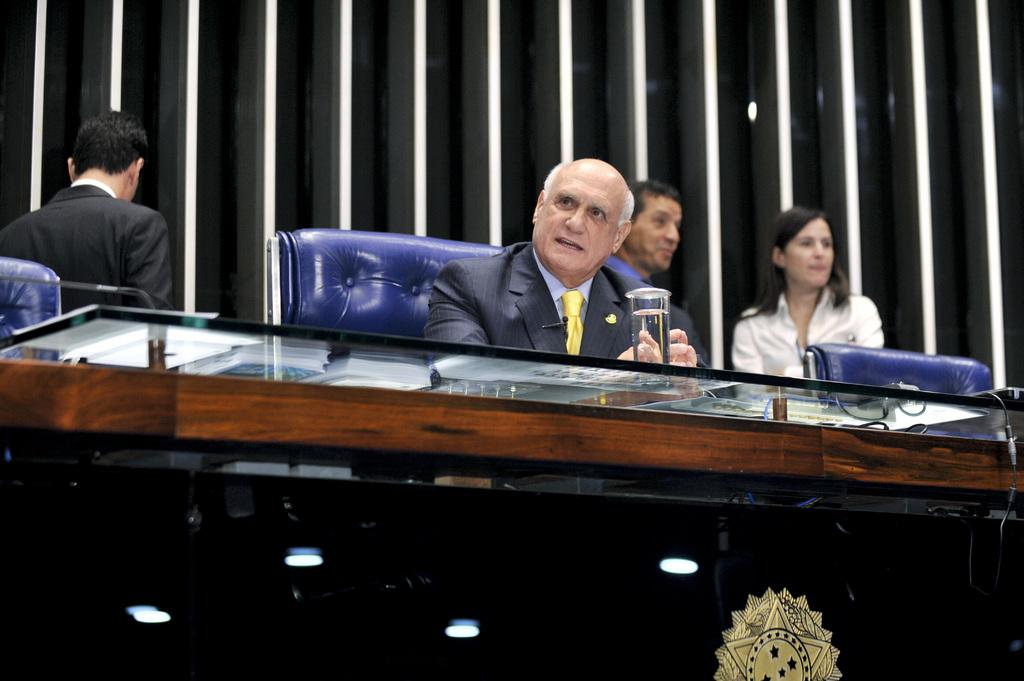How many people are present in the image? There are three people standing in the image, and one person seated on a chair. What objects can be seen on the table in the image? There is a glass of water and a microphone on the table. What type of sheet is being discussed by the people in the image? There is no sheet or discussion about a sheet present in the image. How many flies can be seen buzzing around the microphone in the image? There are no flies present in the image. 